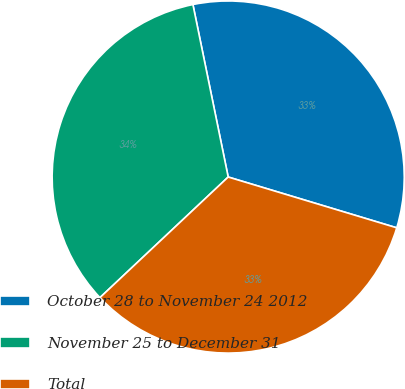Convert chart. <chart><loc_0><loc_0><loc_500><loc_500><pie_chart><fcel>October 28 to November 24 2012<fcel>November 25 to December 31<fcel>Total<nl><fcel>32.87%<fcel>33.8%<fcel>33.33%<nl></chart> 